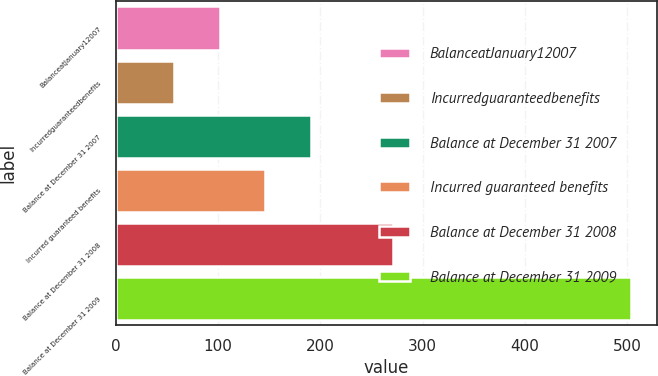Convert chart to OTSL. <chart><loc_0><loc_0><loc_500><loc_500><bar_chart><fcel>BalanceatJanuary12007<fcel>Incurredguaranteedbenefits<fcel>Balance at December 31 2007<fcel>Incurred guaranteed benefits<fcel>Balance at December 31 2008<fcel>Balance at December 31 2009<nl><fcel>101.7<fcel>57<fcel>191.1<fcel>146.4<fcel>271<fcel>504<nl></chart> 